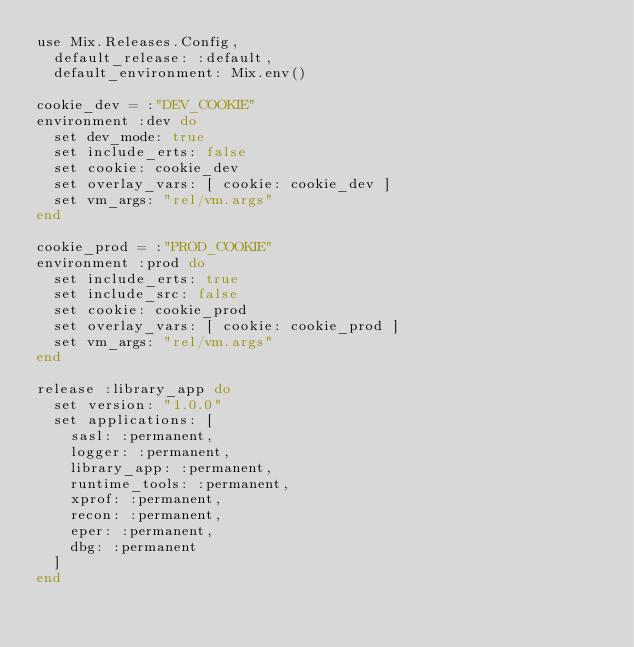<code> <loc_0><loc_0><loc_500><loc_500><_Elixir_>use Mix.Releases.Config,
  default_release: :default,
  default_environment: Mix.env()

cookie_dev = :"DEV_COOKIE"
environment :dev do
  set dev_mode: true
  set include_erts: false
  set cookie: cookie_dev
  set overlay_vars: [ cookie: cookie_dev ]
  set vm_args: "rel/vm.args"
end

cookie_prod = :"PROD_COOKIE"
environment :prod do
  set include_erts: true
  set include_src: false
  set cookie: cookie_prod
  set overlay_vars: [ cookie: cookie_prod ]
  set vm_args: "rel/vm.args"
end

release :library_app do
  set version: "1.0.0"
  set applications: [
    sasl: :permanent,
    logger: :permanent,
    library_app: :permanent,
    runtime_tools: :permanent,
    xprof: :permanent,
    recon: :permanent,
    eper: :permanent,
    dbg: :permanent
  ]
end</code> 